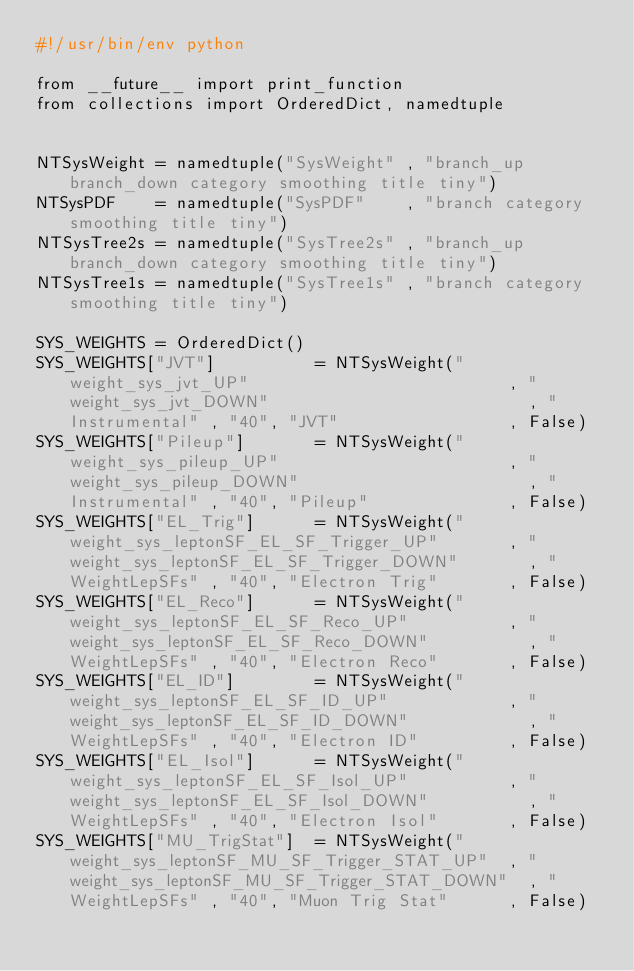Convert code to text. <code><loc_0><loc_0><loc_500><loc_500><_Python_>#!/usr/bin/env python

from __future__ import print_function
from collections import OrderedDict, namedtuple


NTSysWeight = namedtuple("SysWeight" , "branch_up branch_down category smoothing title tiny")
NTSysPDF    = namedtuple("SysPDF"    , "branch category smoothing title tiny")
NTSysTree2s = namedtuple("SysTree2s" , "branch_up branch_down category smoothing title tiny")
NTSysTree1s = namedtuple("SysTree1s" , "branch category smoothing title tiny")

SYS_WEIGHTS = OrderedDict()
SYS_WEIGHTS["JVT"]          = NTSysWeight("weight_sys_jvt_UP"                          , "weight_sys_jvt_DOWN"                          , "Instrumental" , "40", "JVT"                 , False)
SYS_WEIGHTS["Pileup"]       = NTSysWeight("weight_sys_pileup_UP"                       , "weight_sys_pileup_DOWN"                       , "Instrumental" , "40", "Pileup"              , False)
SYS_WEIGHTS["EL_Trig"]      = NTSysWeight("weight_sys_leptonSF_EL_SF_Trigger_UP"       , "weight_sys_leptonSF_EL_SF_Trigger_DOWN"       , "WeightLepSFs" , "40", "Electron Trig"       , False)
SYS_WEIGHTS["EL_Reco"]      = NTSysWeight("weight_sys_leptonSF_EL_SF_Reco_UP"          , "weight_sys_leptonSF_EL_SF_Reco_DOWN"          , "WeightLepSFs" , "40", "Electron Reco"       , False)
SYS_WEIGHTS["EL_ID"]        = NTSysWeight("weight_sys_leptonSF_EL_SF_ID_UP"            , "weight_sys_leptonSF_EL_SF_ID_DOWN"            , "WeightLepSFs" , "40", "Electron ID"         , False)
SYS_WEIGHTS["EL_Isol"]      = NTSysWeight("weight_sys_leptonSF_EL_SF_Isol_UP"          , "weight_sys_leptonSF_EL_SF_Isol_DOWN"          , "WeightLepSFs" , "40", "Electron Isol"       , False)
SYS_WEIGHTS["MU_TrigStat"]  = NTSysWeight("weight_sys_leptonSF_MU_SF_Trigger_STAT_UP"  , "weight_sys_leptonSF_MU_SF_Trigger_STAT_DOWN"  , "WeightLepSFs" , "40", "Muon Trig Stat"      , False)</code> 